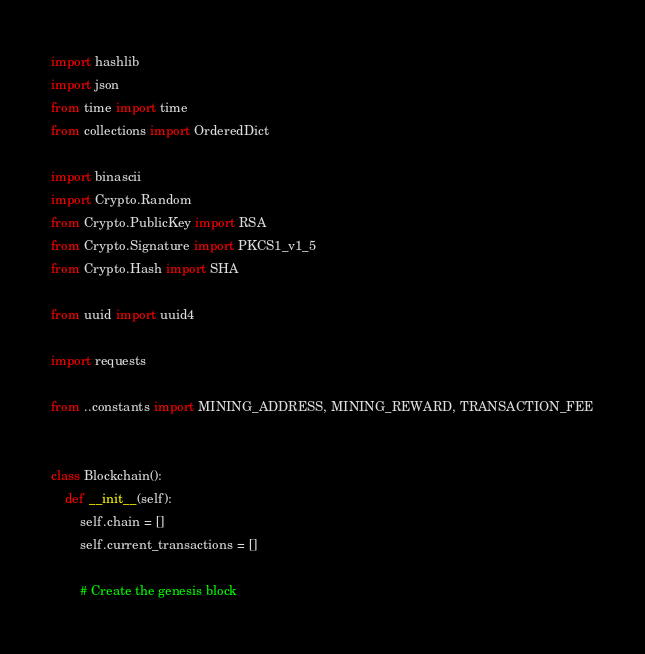<code> <loc_0><loc_0><loc_500><loc_500><_Python_>import hashlib
import json
from time import time
from collections import OrderedDict

import binascii
import Crypto.Random
from Crypto.PublicKey import RSA
from Crypto.Signature import PKCS1_v1_5
from Crypto.Hash import SHA

from uuid import uuid4

import requests

from ..constants import MINING_ADDRESS, MINING_REWARD, TRANSACTION_FEE


class Blockchain():
    def __init__(self):
        self.chain = []
        self.current_transactions = []

        # Create the genesis block</code> 